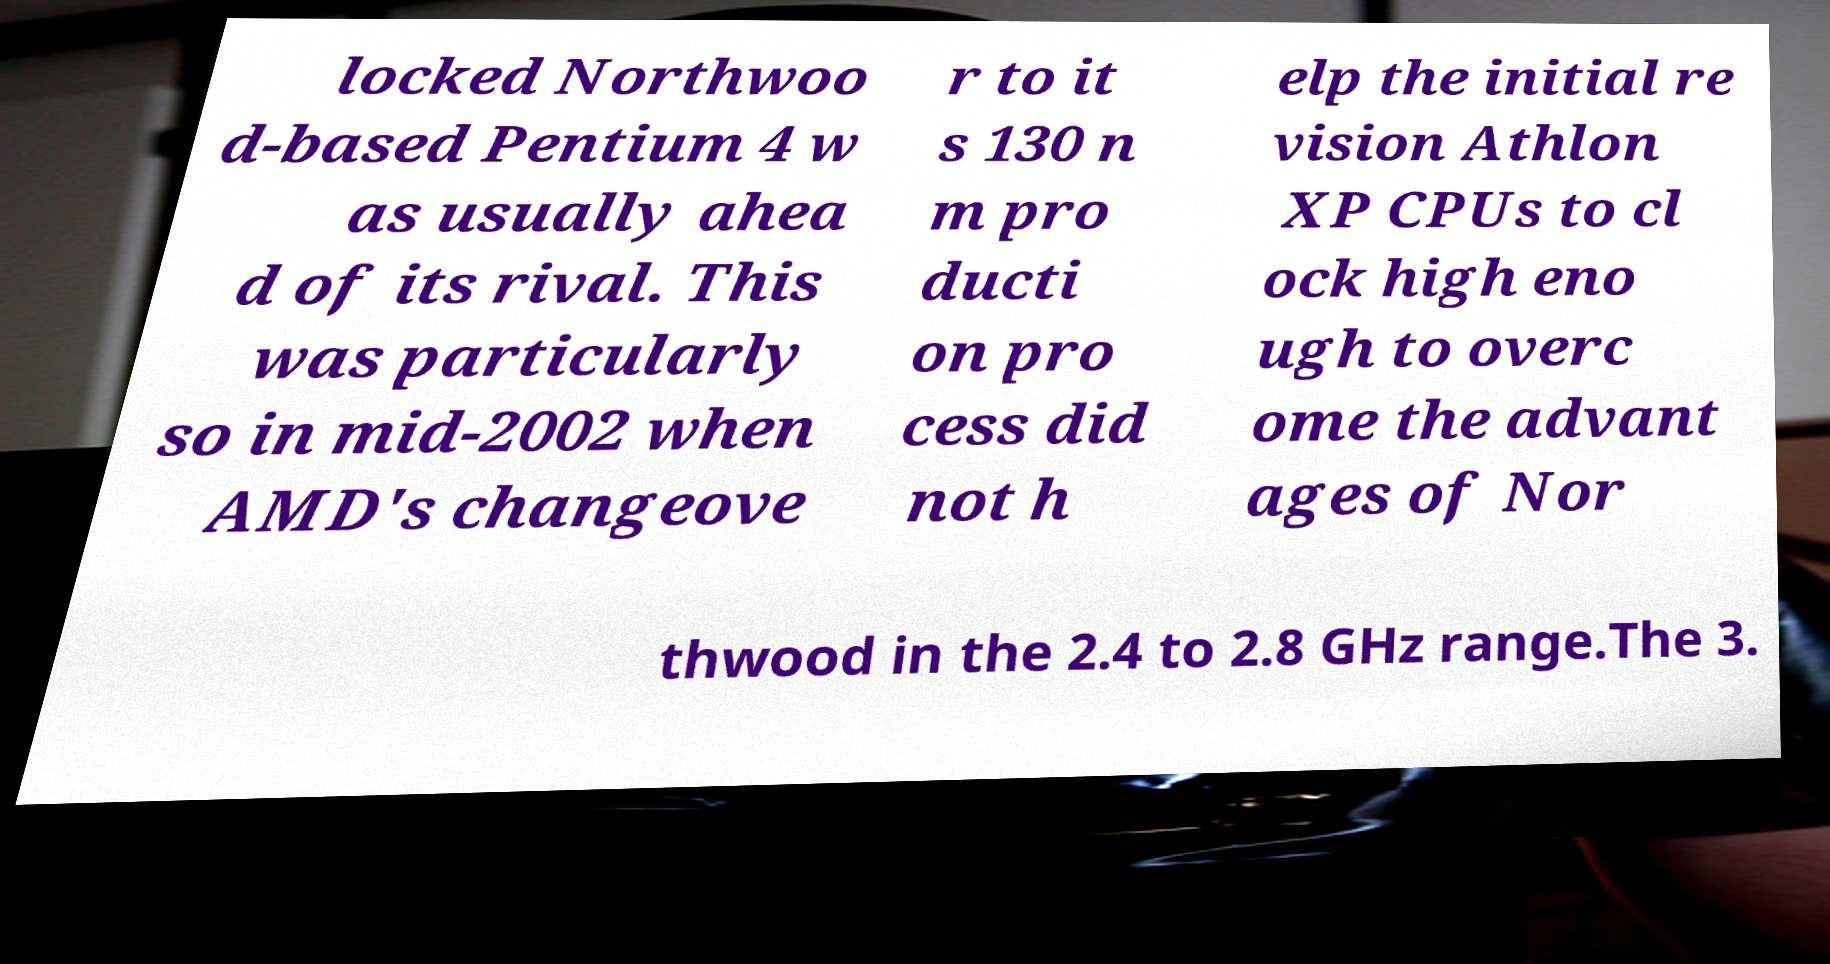What messages or text are displayed in this image? I need them in a readable, typed format. locked Northwoo d-based Pentium 4 w as usually ahea d of its rival. This was particularly so in mid-2002 when AMD's changeove r to it s 130 n m pro ducti on pro cess did not h elp the initial re vision Athlon XP CPUs to cl ock high eno ugh to overc ome the advant ages of Nor thwood in the 2.4 to 2.8 GHz range.The 3. 